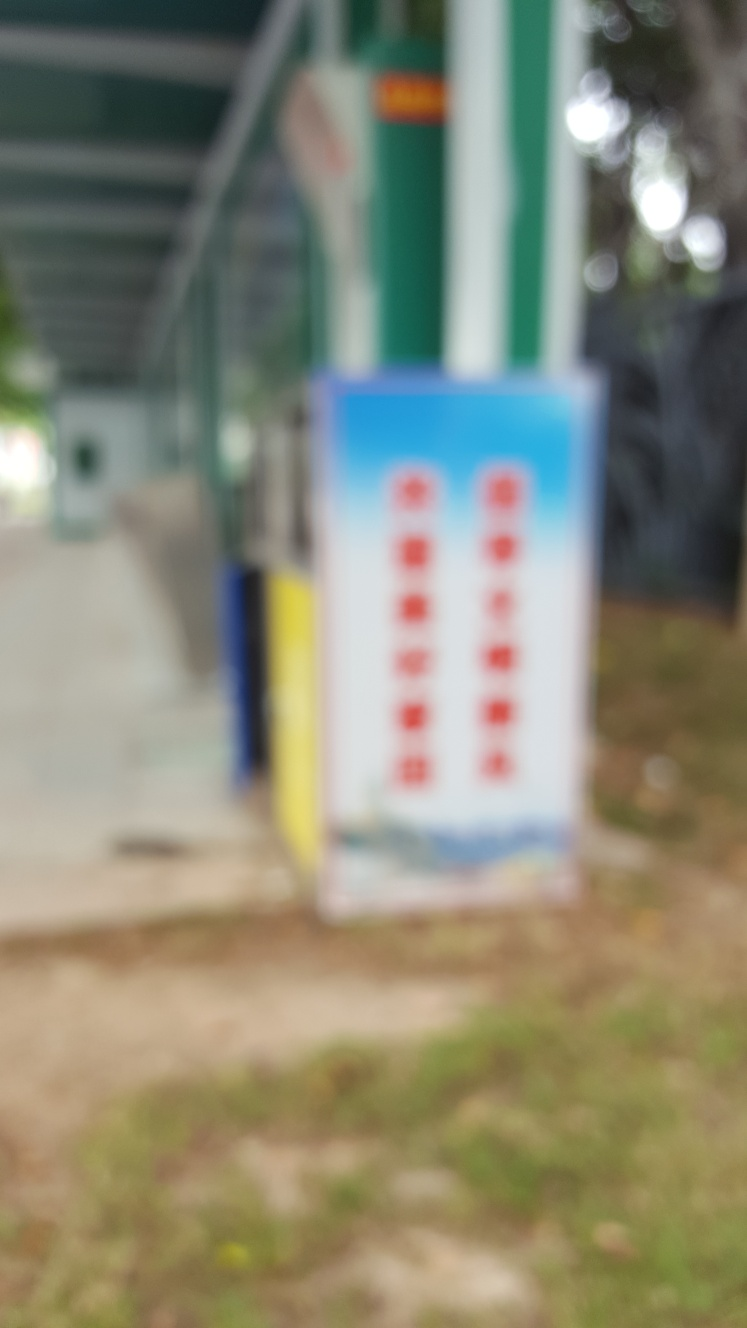Could you describe the setting or environment where this picture was taken? Although the photo is blurry, it appears to be an outdoor setting with natural light. There are vertical structures that could be poles or trees, and the edge of a building can be seen on the left. The ground looks uneven and may be natural terrain or a grassy area, suggesting a park or a similarly landscaped outdoor space. 